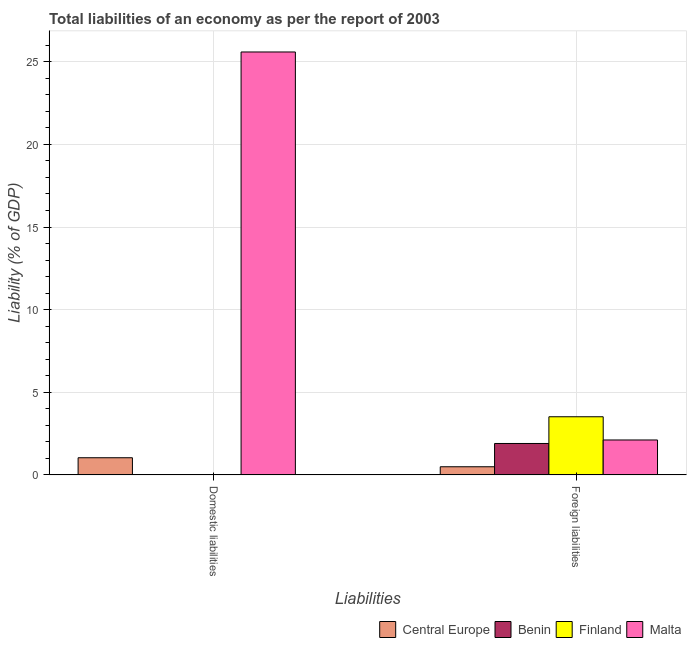Are the number of bars per tick equal to the number of legend labels?
Keep it short and to the point. No. Are the number of bars on each tick of the X-axis equal?
Offer a terse response. No. How many bars are there on the 2nd tick from the left?
Offer a very short reply. 4. What is the label of the 2nd group of bars from the left?
Make the answer very short. Foreign liabilities. What is the incurrence of foreign liabilities in Finland?
Your answer should be very brief. 3.52. Across all countries, what is the maximum incurrence of foreign liabilities?
Ensure brevity in your answer.  3.52. Across all countries, what is the minimum incurrence of domestic liabilities?
Your answer should be compact. 0. In which country was the incurrence of domestic liabilities maximum?
Give a very brief answer. Malta. What is the total incurrence of foreign liabilities in the graph?
Offer a terse response. 8.03. What is the difference between the incurrence of foreign liabilities in Benin and that in Finland?
Keep it short and to the point. -1.62. What is the difference between the incurrence of domestic liabilities in Malta and the incurrence of foreign liabilities in Central Europe?
Your answer should be very brief. 25.1. What is the average incurrence of domestic liabilities per country?
Keep it short and to the point. 6.66. What is the difference between the incurrence of foreign liabilities and incurrence of domestic liabilities in Central Europe?
Ensure brevity in your answer.  -0.55. What is the ratio of the incurrence of foreign liabilities in Benin to that in Malta?
Your answer should be very brief. 0.9. In how many countries, is the incurrence of foreign liabilities greater than the average incurrence of foreign liabilities taken over all countries?
Make the answer very short. 2. How many bars are there?
Make the answer very short. 6. How many countries are there in the graph?
Keep it short and to the point. 4. What is the difference between two consecutive major ticks on the Y-axis?
Keep it short and to the point. 5. How are the legend labels stacked?
Offer a terse response. Horizontal. What is the title of the graph?
Your answer should be compact. Total liabilities of an economy as per the report of 2003. What is the label or title of the X-axis?
Make the answer very short. Liabilities. What is the label or title of the Y-axis?
Your response must be concise. Liability (% of GDP). What is the Liability (% of GDP) of Central Europe in Domestic liabilities?
Keep it short and to the point. 1.04. What is the Liability (% of GDP) in Malta in Domestic liabilities?
Your answer should be very brief. 25.59. What is the Liability (% of GDP) in Central Europe in Foreign liabilities?
Offer a very short reply. 0.49. What is the Liability (% of GDP) in Benin in Foreign liabilities?
Ensure brevity in your answer.  1.9. What is the Liability (% of GDP) of Finland in Foreign liabilities?
Give a very brief answer. 3.52. What is the Liability (% of GDP) of Malta in Foreign liabilities?
Provide a succinct answer. 2.11. Across all Liabilities, what is the maximum Liability (% of GDP) of Central Europe?
Your answer should be very brief. 1.04. Across all Liabilities, what is the maximum Liability (% of GDP) of Benin?
Provide a short and direct response. 1.9. Across all Liabilities, what is the maximum Liability (% of GDP) of Finland?
Your answer should be compact. 3.52. Across all Liabilities, what is the maximum Liability (% of GDP) in Malta?
Offer a very short reply. 25.59. Across all Liabilities, what is the minimum Liability (% of GDP) in Central Europe?
Provide a short and direct response. 0.49. Across all Liabilities, what is the minimum Liability (% of GDP) of Benin?
Give a very brief answer. 0. Across all Liabilities, what is the minimum Liability (% of GDP) in Malta?
Your answer should be very brief. 2.11. What is the total Liability (% of GDP) in Central Europe in the graph?
Your answer should be compact. 1.53. What is the total Liability (% of GDP) in Benin in the graph?
Your answer should be very brief. 1.9. What is the total Liability (% of GDP) of Finland in the graph?
Offer a terse response. 3.52. What is the total Liability (% of GDP) in Malta in the graph?
Give a very brief answer. 27.7. What is the difference between the Liability (% of GDP) of Central Europe in Domestic liabilities and that in Foreign liabilities?
Provide a succinct answer. 0.55. What is the difference between the Liability (% of GDP) of Malta in Domestic liabilities and that in Foreign liabilities?
Provide a short and direct response. 23.47. What is the difference between the Liability (% of GDP) in Central Europe in Domestic liabilities and the Liability (% of GDP) in Benin in Foreign liabilities?
Give a very brief answer. -0.86. What is the difference between the Liability (% of GDP) in Central Europe in Domestic liabilities and the Liability (% of GDP) in Finland in Foreign liabilities?
Offer a terse response. -2.48. What is the difference between the Liability (% of GDP) in Central Europe in Domestic liabilities and the Liability (% of GDP) in Malta in Foreign liabilities?
Give a very brief answer. -1.07. What is the average Liability (% of GDP) of Central Europe per Liabilities?
Your answer should be compact. 0.77. What is the average Liability (% of GDP) in Benin per Liabilities?
Make the answer very short. 0.95. What is the average Liability (% of GDP) of Finland per Liabilities?
Provide a short and direct response. 1.76. What is the average Liability (% of GDP) of Malta per Liabilities?
Keep it short and to the point. 13.85. What is the difference between the Liability (% of GDP) in Central Europe and Liability (% of GDP) in Malta in Domestic liabilities?
Provide a short and direct response. -24.55. What is the difference between the Liability (% of GDP) in Central Europe and Liability (% of GDP) in Benin in Foreign liabilities?
Give a very brief answer. -1.41. What is the difference between the Liability (% of GDP) of Central Europe and Liability (% of GDP) of Finland in Foreign liabilities?
Give a very brief answer. -3.03. What is the difference between the Liability (% of GDP) of Central Europe and Liability (% of GDP) of Malta in Foreign liabilities?
Provide a short and direct response. -1.62. What is the difference between the Liability (% of GDP) of Benin and Liability (% of GDP) of Finland in Foreign liabilities?
Offer a very short reply. -1.62. What is the difference between the Liability (% of GDP) in Benin and Liability (% of GDP) in Malta in Foreign liabilities?
Provide a succinct answer. -0.21. What is the difference between the Liability (% of GDP) of Finland and Liability (% of GDP) of Malta in Foreign liabilities?
Provide a short and direct response. 1.41. What is the ratio of the Liability (% of GDP) of Central Europe in Domestic liabilities to that in Foreign liabilities?
Provide a short and direct response. 2.1. What is the ratio of the Liability (% of GDP) of Malta in Domestic liabilities to that in Foreign liabilities?
Give a very brief answer. 12.1. What is the difference between the highest and the second highest Liability (% of GDP) of Central Europe?
Provide a short and direct response. 0.55. What is the difference between the highest and the second highest Liability (% of GDP) of Malta?
Ensure brevity in your answer.  23.47. What is the difference between the highest and the lowest Liability (% of GDP) of Central Europe?
Provide a short and direct response. 0.55. What is the difference between the highest and the lowest Liability (% of GDP) of Benin?
Your answer should be compact. 1.9. What is the difference between the highest and the lowest Liability (% of GDP) in Finland?
Make the answer very short. 3.52. What is the difference between the highest and the lowest Liability (% of GDP) of Malta?
Provide a short and direct response. 23.47. 